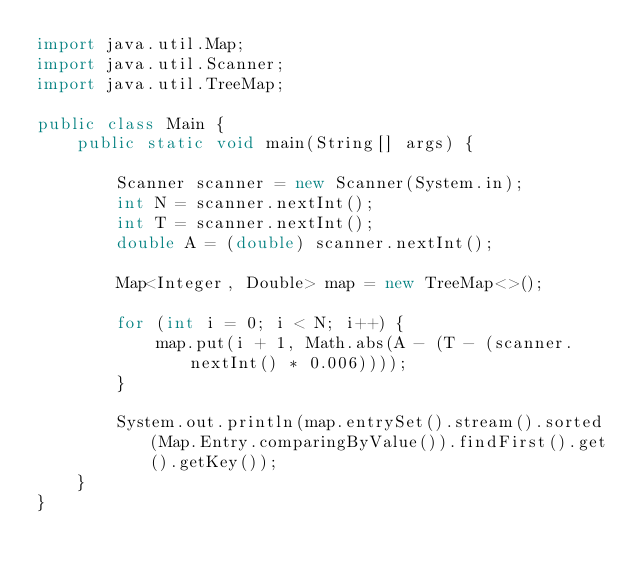<code> <loc_0><loc_0><loc_500><loc_500><_Java_>import java.util.Map;
import java.util.Scanner;
import java.util.TreeMap;

public class Main {
    public static void main(String[] args) {

        Scanner scanner = new Scanner(System.in);
        int N = scanner.nextInt();
        int T = scanner.nextInt();
        double A = (double) scanner.nextInt();

        Map<Integer, Double> map = new TreeMap<>();

        for (int i = 0; i < N; i++) {
            map.put(i + 1, Math.abs(A - (T - (scanner.nextInt() * 0.006))));
        }

        System.out.println(map.entrySet().stream().sorted(Map.Entry.comparingByValue()).findFirst().get().getKey());
    }
}</code> 